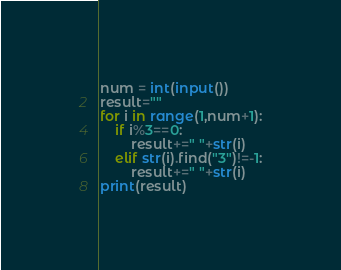Convert code to text. <code><loc_0><loc_0><loc_500><loc_500><_Python_>num = int(input())
result=""
for i in range(1,num+1):
    if i%3==0:
        result+=" "+str(i)
    elif str(i).find("3")!=-1:
        result+=" "+str(i)
print(result)

</code> 